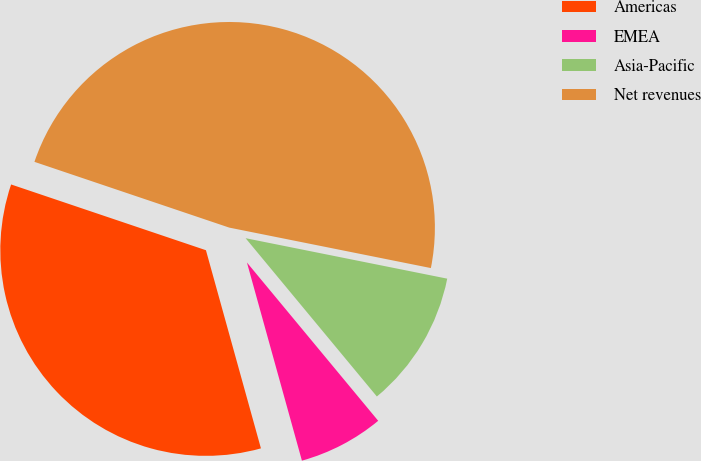Convert chart. <chart><loc_0><loc_0><loc_500><loc_500><pie_chart><fcel>Americas<fcel>EMEA<fcel>Asia-Pacific<fcel>Net revenues<nl><fcel>34.49%<fcel>6.71%<fcel>10.83%<fcel>47.97%<nl></chart> 